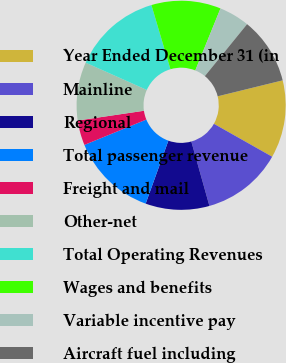Convert chart. <chart><loc_0><loc_0><loc_500><loc_500><pie_chart><fcel>Year Ended December 31 (in<fcel>Mainline<fcel>Regional<fcel>Total passenger revenue<fcel>Freight and mail<fcel>Other-net<fcel>Total Operating Revenues<fcel>Wages and benefits<fcel>Variable incentive pay<fcel>Aircraft fuel including<nl><fcel>12.02%<fcel>12.45%<fcel>9.87%<fcel>13.3%<fcel>3.86%<fcel>9.01%<fcel>13.73%<fcel>10.73%<fcel>4.72%<fcel>10.3%<nl></chart> 